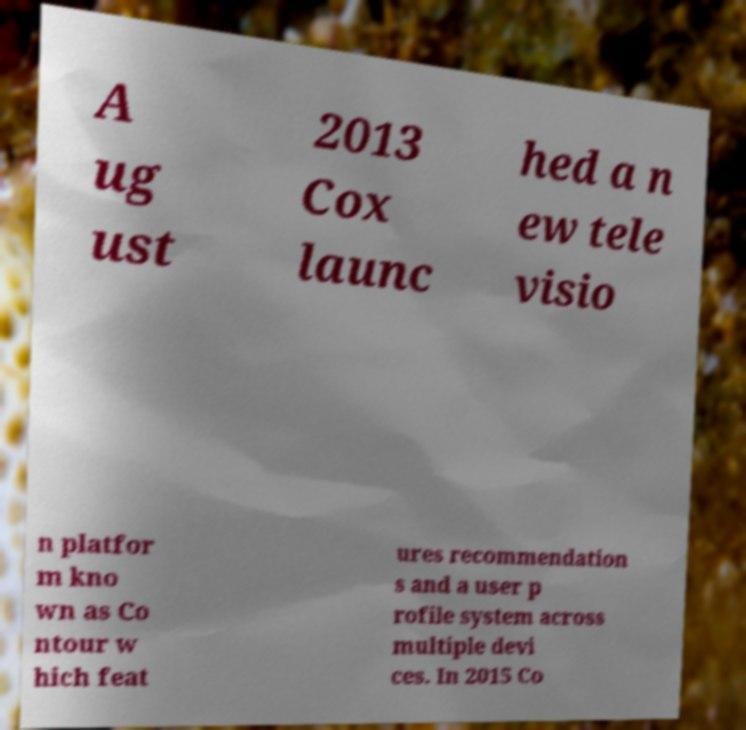I need the written content from this picture converted into text. Can you do that? A ug ust 2013 Cox launc hed a n ew tele visio n platfor m kno wn as Co ntour w hich feat ures recommendation s and a user p rofile system across multiple devi ces. In 2015 Co 